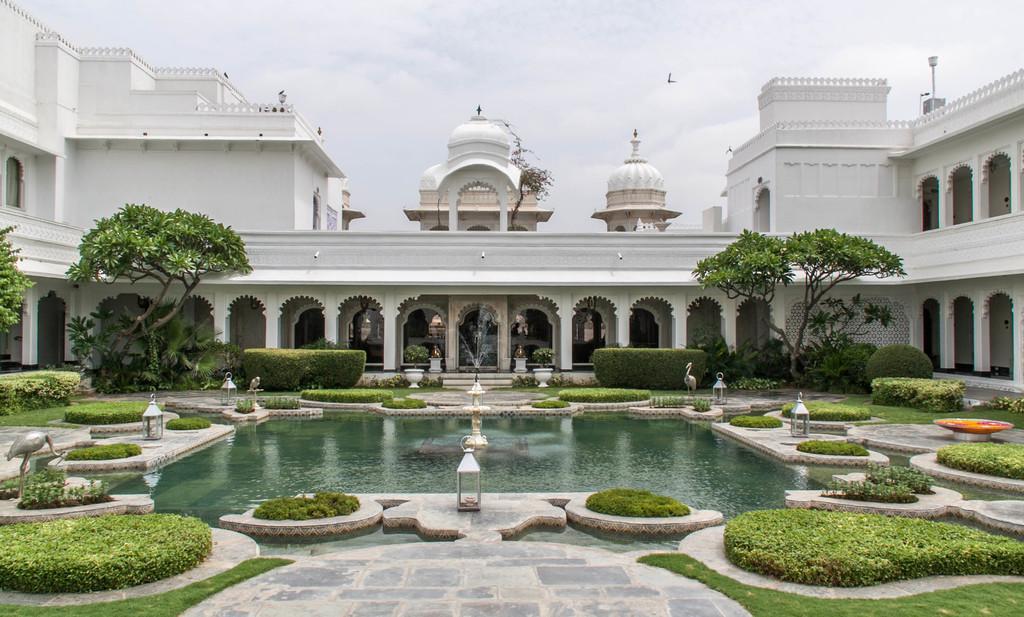Could you give a brief overview of what you see in this image? In the center of the image there is a fountain. There are lamps. There are depictions of cranes. There are plants, trees. In the background of the image there is a building and there is sky. 